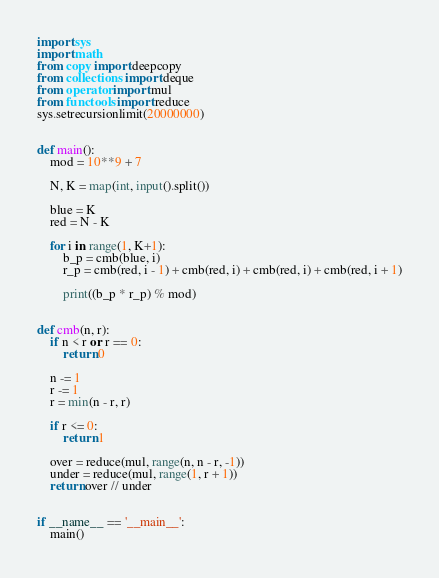<code> <loc_0><loc_0><loc_500><loc_500><_Python_>import sys
import math
from copy import deepcopy
from collections import deque
from operator import mul
from functools import reduce
sys.setrecursionlimit(20000000)


def main():
    mod = 10**9 + 7

    N, K = map(int, input().split())

    blue = K
    red = N - K

    for i in range(1, K+1):
        b_p = cmb(blue, i)
        r_p = cmb(red, i - 1) + cmb(red, i) + cmb(red, i) + cmb(red, i + 1)

        print((b_p * r_p) % mod)


def cmb(n, r):
    if n < r or r == 0:
        return 0

    n -= 1
    r -= 1
    r = min(n - r, r)

    if r <= 0:
        return 1

    over = reduce(mul, range(n, n - r, -1))
    under = reduce(mul, range(1, r + 1))
    return over // under


if __name__ == '__main__':
    main()

</code> 